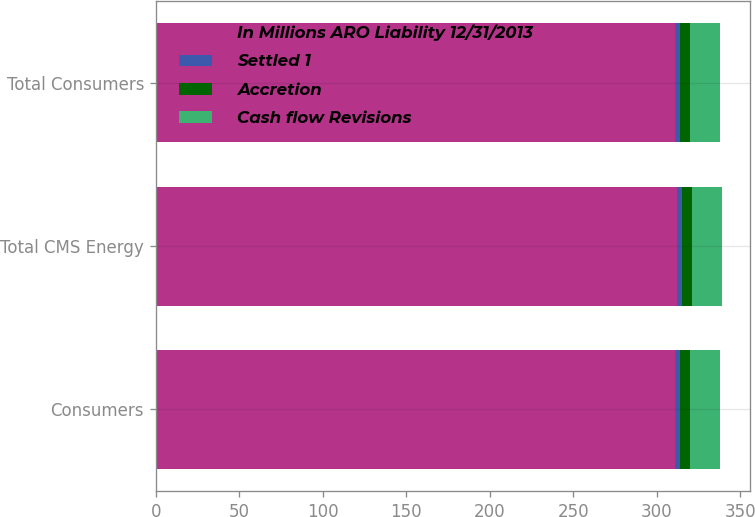Convert chart to OTSL. <chart><loc_0><loc_0><loc_500><loc_500><stacked_bar_chart><ecel><fcel>Consumers<fcel>Total CMS Energy<fcel>Total Consumers<nl><fcel>In Millions ARO Liability 12/31/2013<fcel>311<fcel>312<fcel>311<nl><fcel>Settled 1<fcel>3<fcel>3<fcel>3<nl><fcel>Accretion<fcel>6<fcel>6<fcel>6<nl><fcel>Cash flow Revisions<fcel>18<fcel>18<fcel>18<nl></chart> 